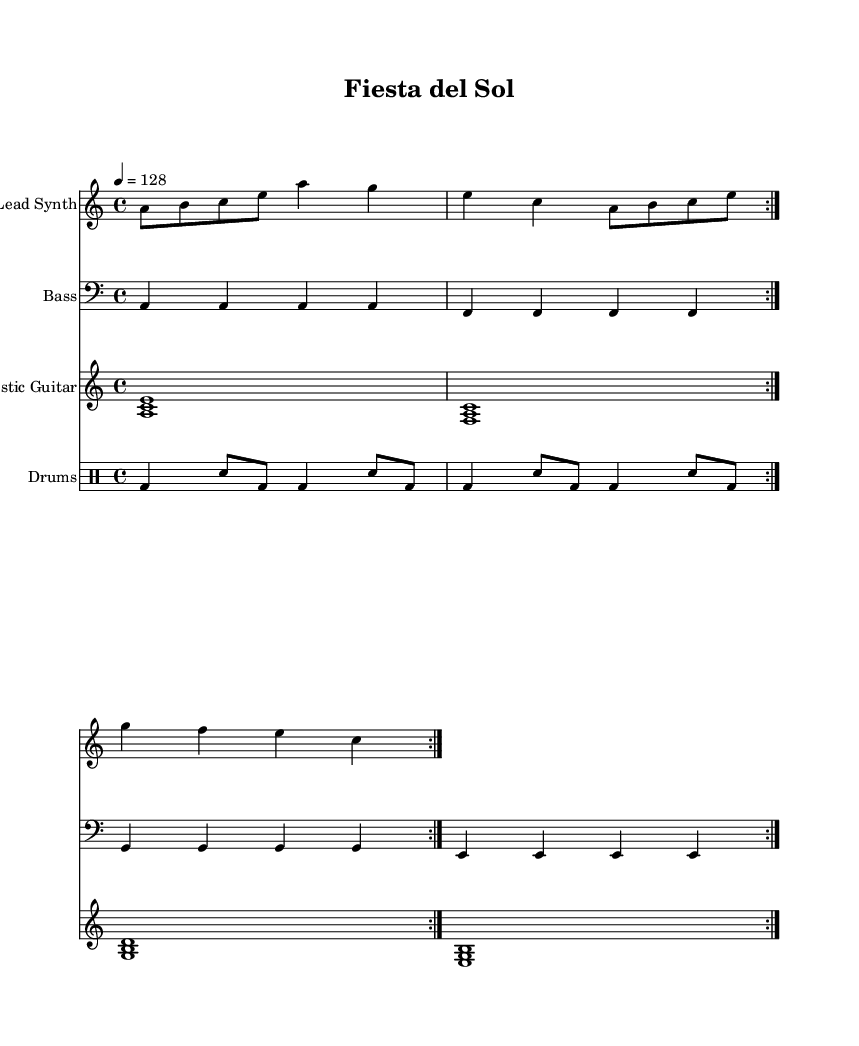What is the key signature of this music? The key signature is A minor, which has no sharps or flats.
Answer: A minor What is the time signature of this music? The time signature is indicated by the "4/4" notation at the beginning of the score, meaning there are four beats in each measure.
Answer: 4/4 What is the tempo of this music? The tempo is indicated as "4 = 128," which means the quarter note gets a beat of 128 beats per minute.
Answer: 128 How many times does the lead synth repeat its section? The lead synth part has a "volta 2" repeat indication, which means it is repeated two times throughout the score.
Answer: 2 What is the instrument playing the bass line? The bass line is played on the instrument labeled as "Bass," indicated in the staff and corresponding clef.
Answer: Bass Which instrument uses chords in its part? The acoustic guitar section features chord voicings such as <a c e> and others. This is distinctive for providing harmonic support.
Answer: Acoustic Guitar What rhythmic pattern is primarily used in the drums part? The drums part shows a pattern of bass drums and snare hits, where a bass drum is played on beats 1 and 3 and a snare on the off-beats.
Answer: Bass and snare 